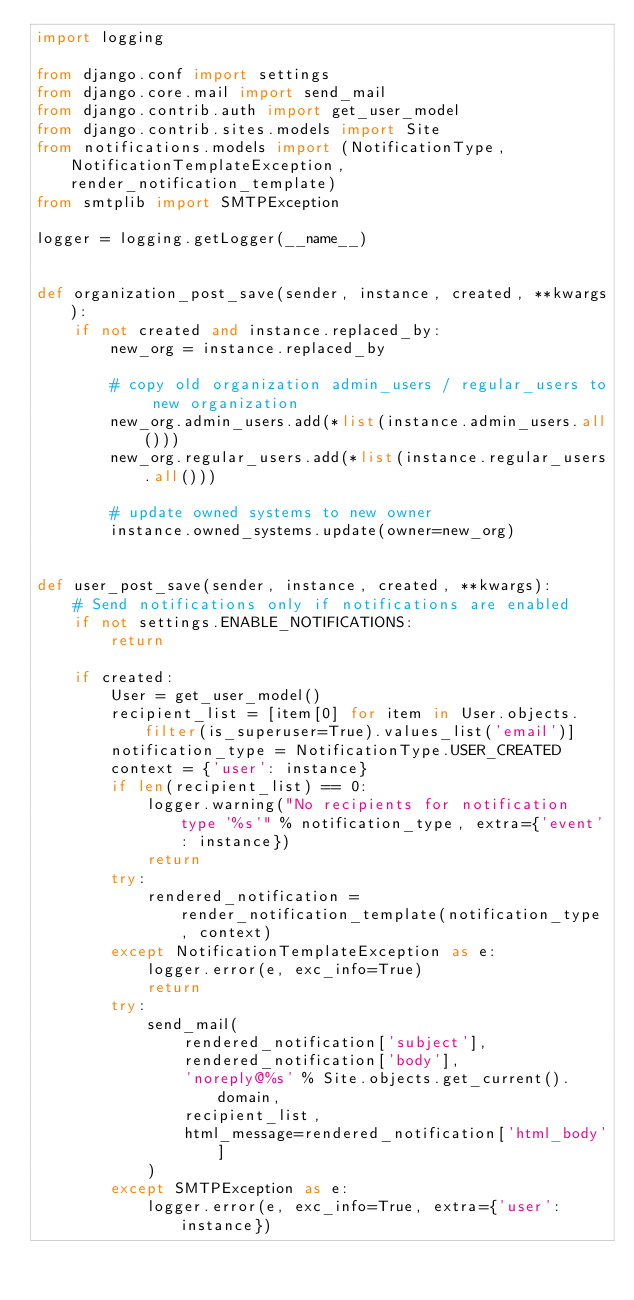Convert code to text. <code><loc_0><loc_0><loc_500><loc_500><_Python_>import logging

from django.conf import settings
from django.core.mail import send_mail
from django.contrib.auth import get_user_model
from django.contrib.sites.models import Site
from notifications.models import (NotificationType, NotificationTemplateException, render_notification_template)
from smtplib import SMTPException

logger = logging.getLogger(__name__)


def organization_post_save(sender, instance, created, **kwargs):
    if not created and instance.replaced_by:
        new_org = instance.replaced_by

        # copy old organization admin_users / regular_users to new organization
        new_org.admin_users.add(*list(instance.admin_users.all()))
        new_org.regular_users.add(*list(instance.regular_users.all()))

        # update owned systems to new owner
        instance.owned_systems.update(owner=new_org)


def user_post_save(sender, instance, created, **kwargs):
    # Send notifications only if notifications are enabled
    if not settings.ENABLE_NOTIFICATIONS:
        return

    if created:
        User = get_user_model()
        recipient_list = [item[0] for item in User.objects.filter(is_superuser=True).values_list('email')]
        notification_type = NotificationType.USER_CREATED
        context = {'user': instance}
        if len(recipient_list) == 0:
            logger.warning("No recipients for notification type '%s'" % notification_type, extra={'event': instance})
            return
        try:
            rendered_notification = render_notification_template(notification_type, context)
        except NotificationTemplateException as e:
            logger.error(e, exc_info=True)
            return
        try:
            send_mail(
                rendered_notification['subject'],
                rendered_notification['body'],
                'noreply@%s' % Site.objects.get_current().domain,
                recipient_list,
                html_message=rendered_notification['html_body']
            )
        except SMTPException as e:
            logger.error(e, exc_info=True, extra={'user': instance})
</code> 